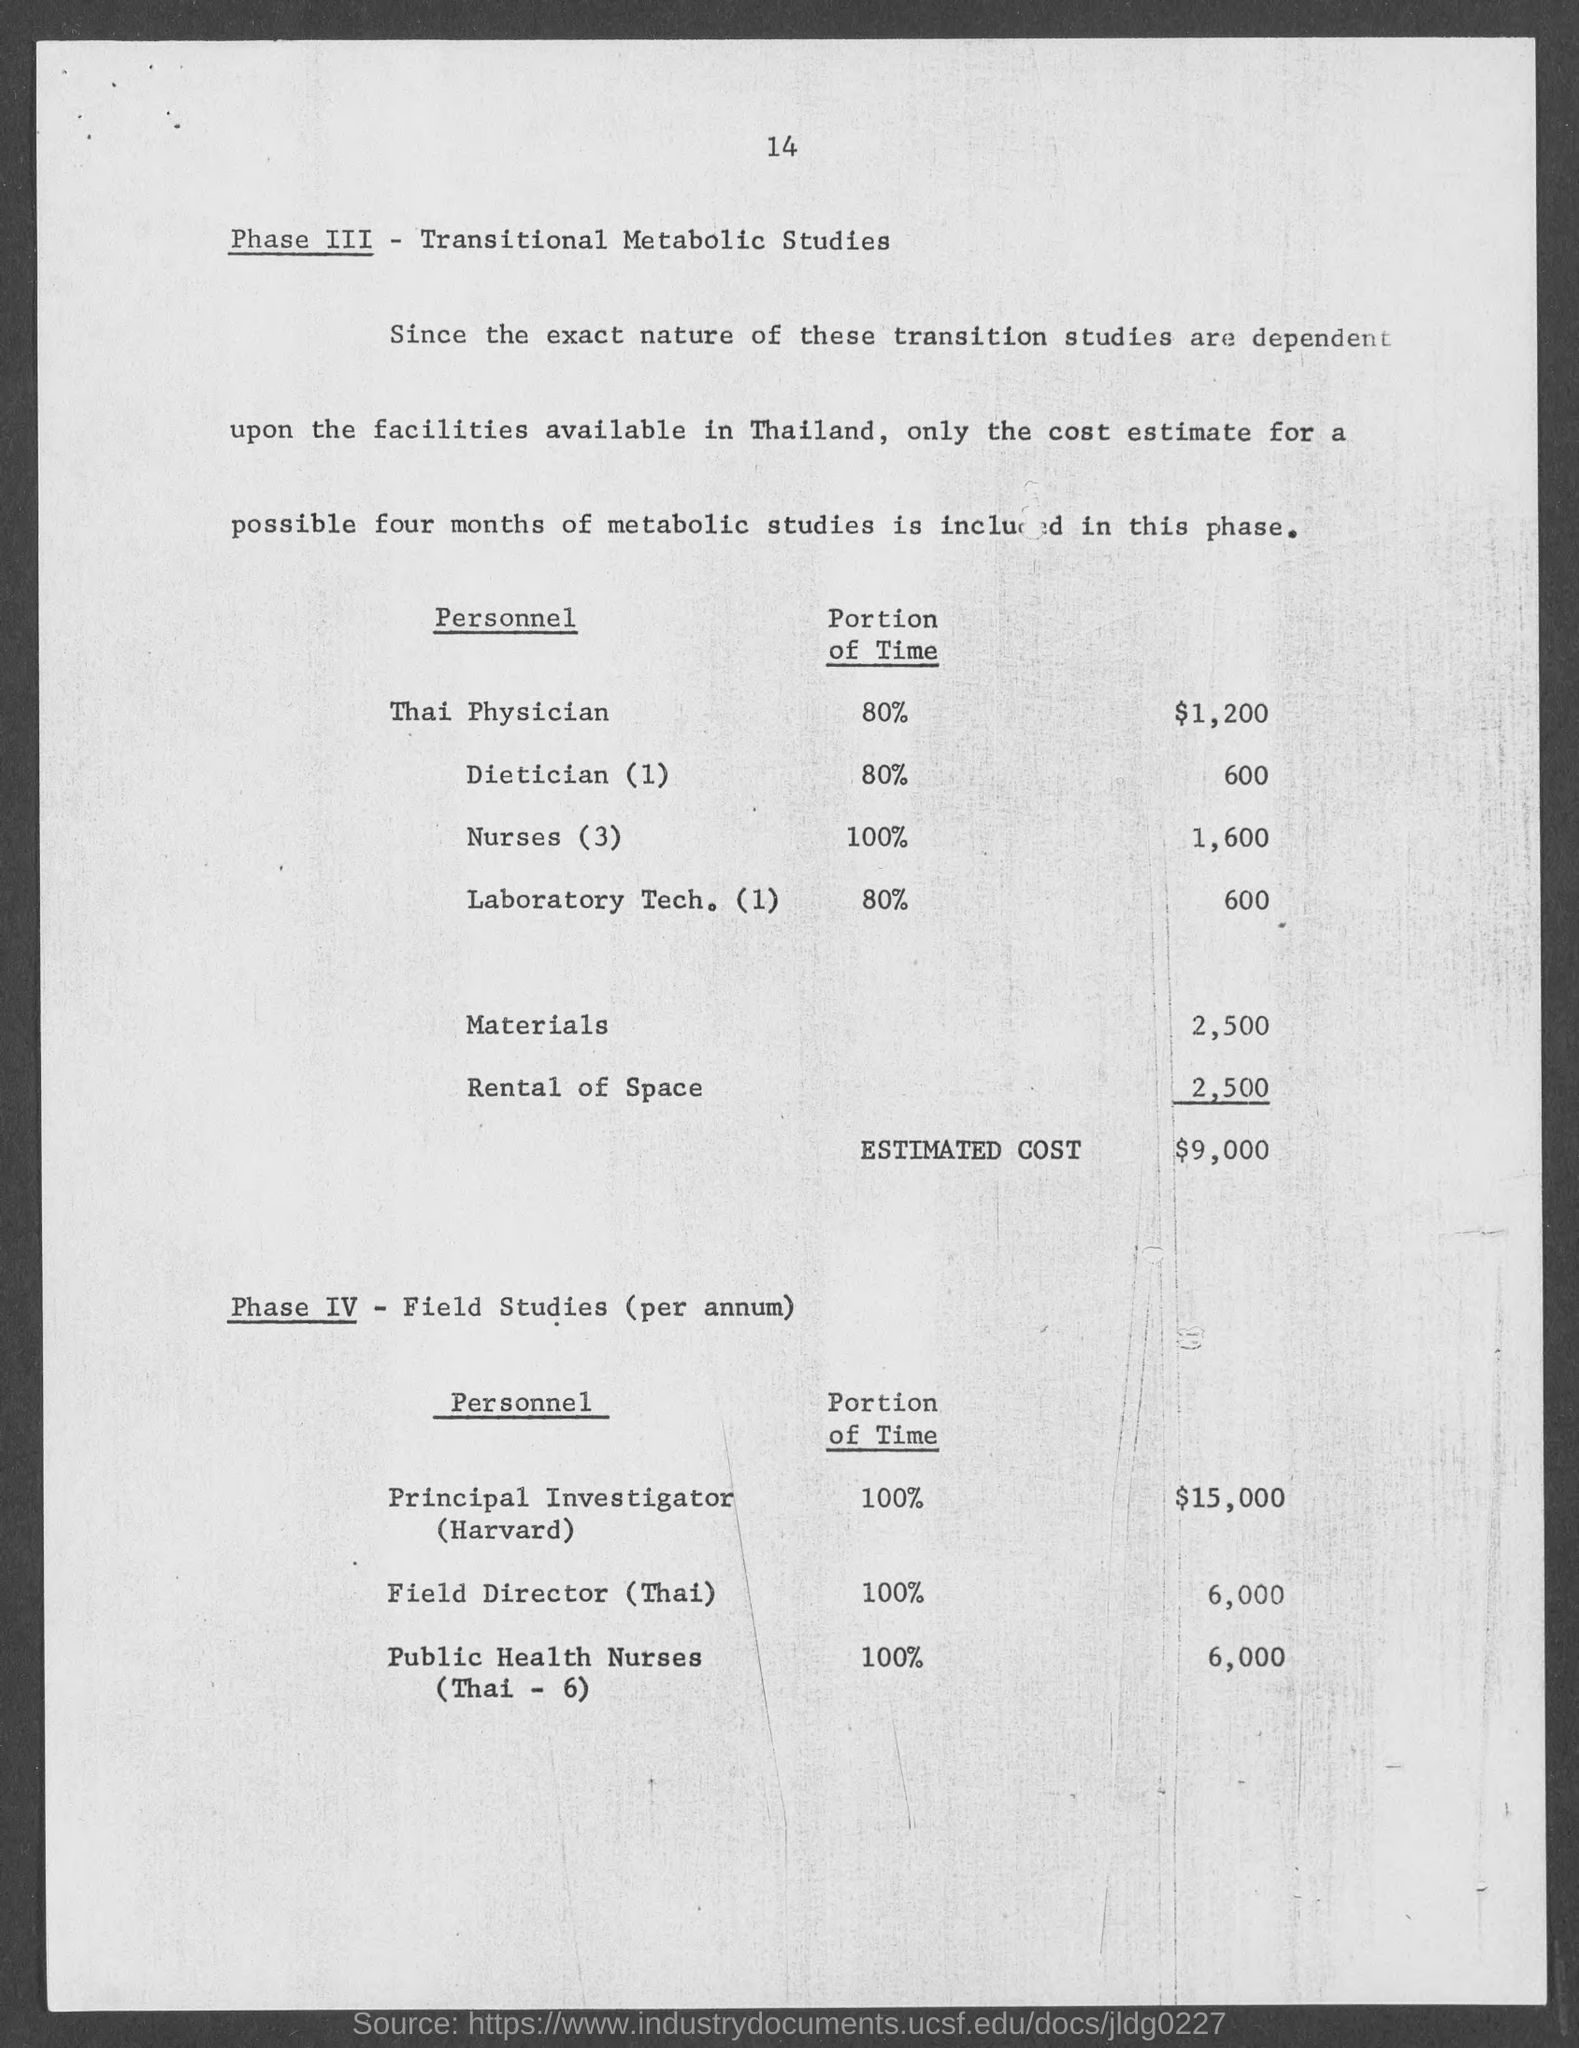What portion of the time is dedicated by the Thai Physician as per the document? According to the document, the Thai Physician dedicates 80% of their time to the Phase III - Transitional Metabolic Studies. 